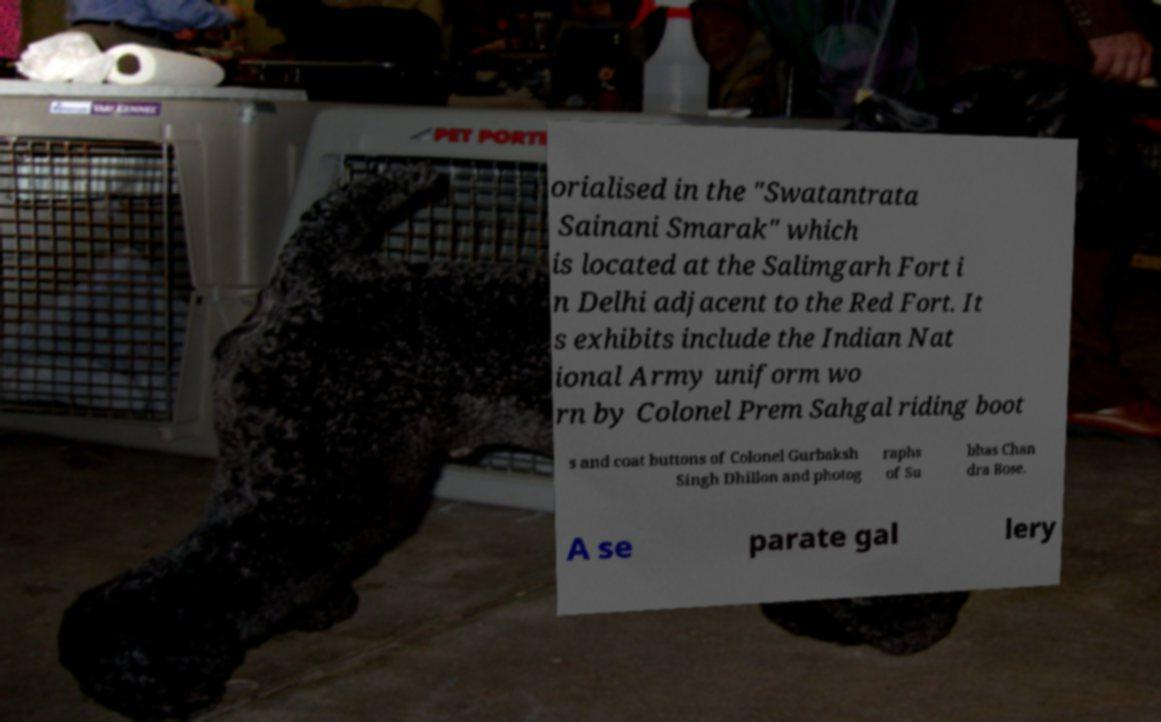Please read and relay the text visible in this image. What does it say? orialised in the "Swatantrata Sainani Smarak" which is located at the Salimgarh Fort i n Delhi adjacent to the Red Fort. It s exhibits include the Indian Nat ional Army uniform wo rn by Colonel Prem Sahgal riding boot s and coat buttons of Colonel Gurbaksh Singh Dhillon and photog raphs of Su bhas Chan dra Bose. A se parate gal lery 